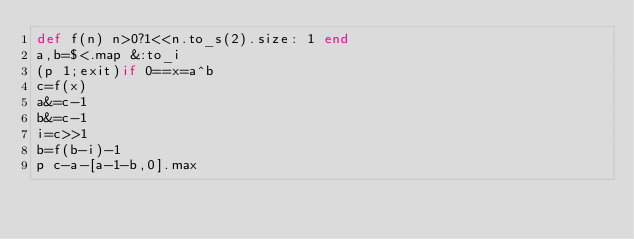<code> <loc_0><loc_0><loc_500><loc_500><_Ruby_>def f(n) n>0?1<<n.to_s(2).size: 1 end
a,b=$<.map &:to_i
(p 1;exit)if 0==x=a^b
c=f(x)
a&=c-1
b&=c-1
i=c>>1
b=f(b-i)-1
p c-a-[a-1-b,0].max</code> 